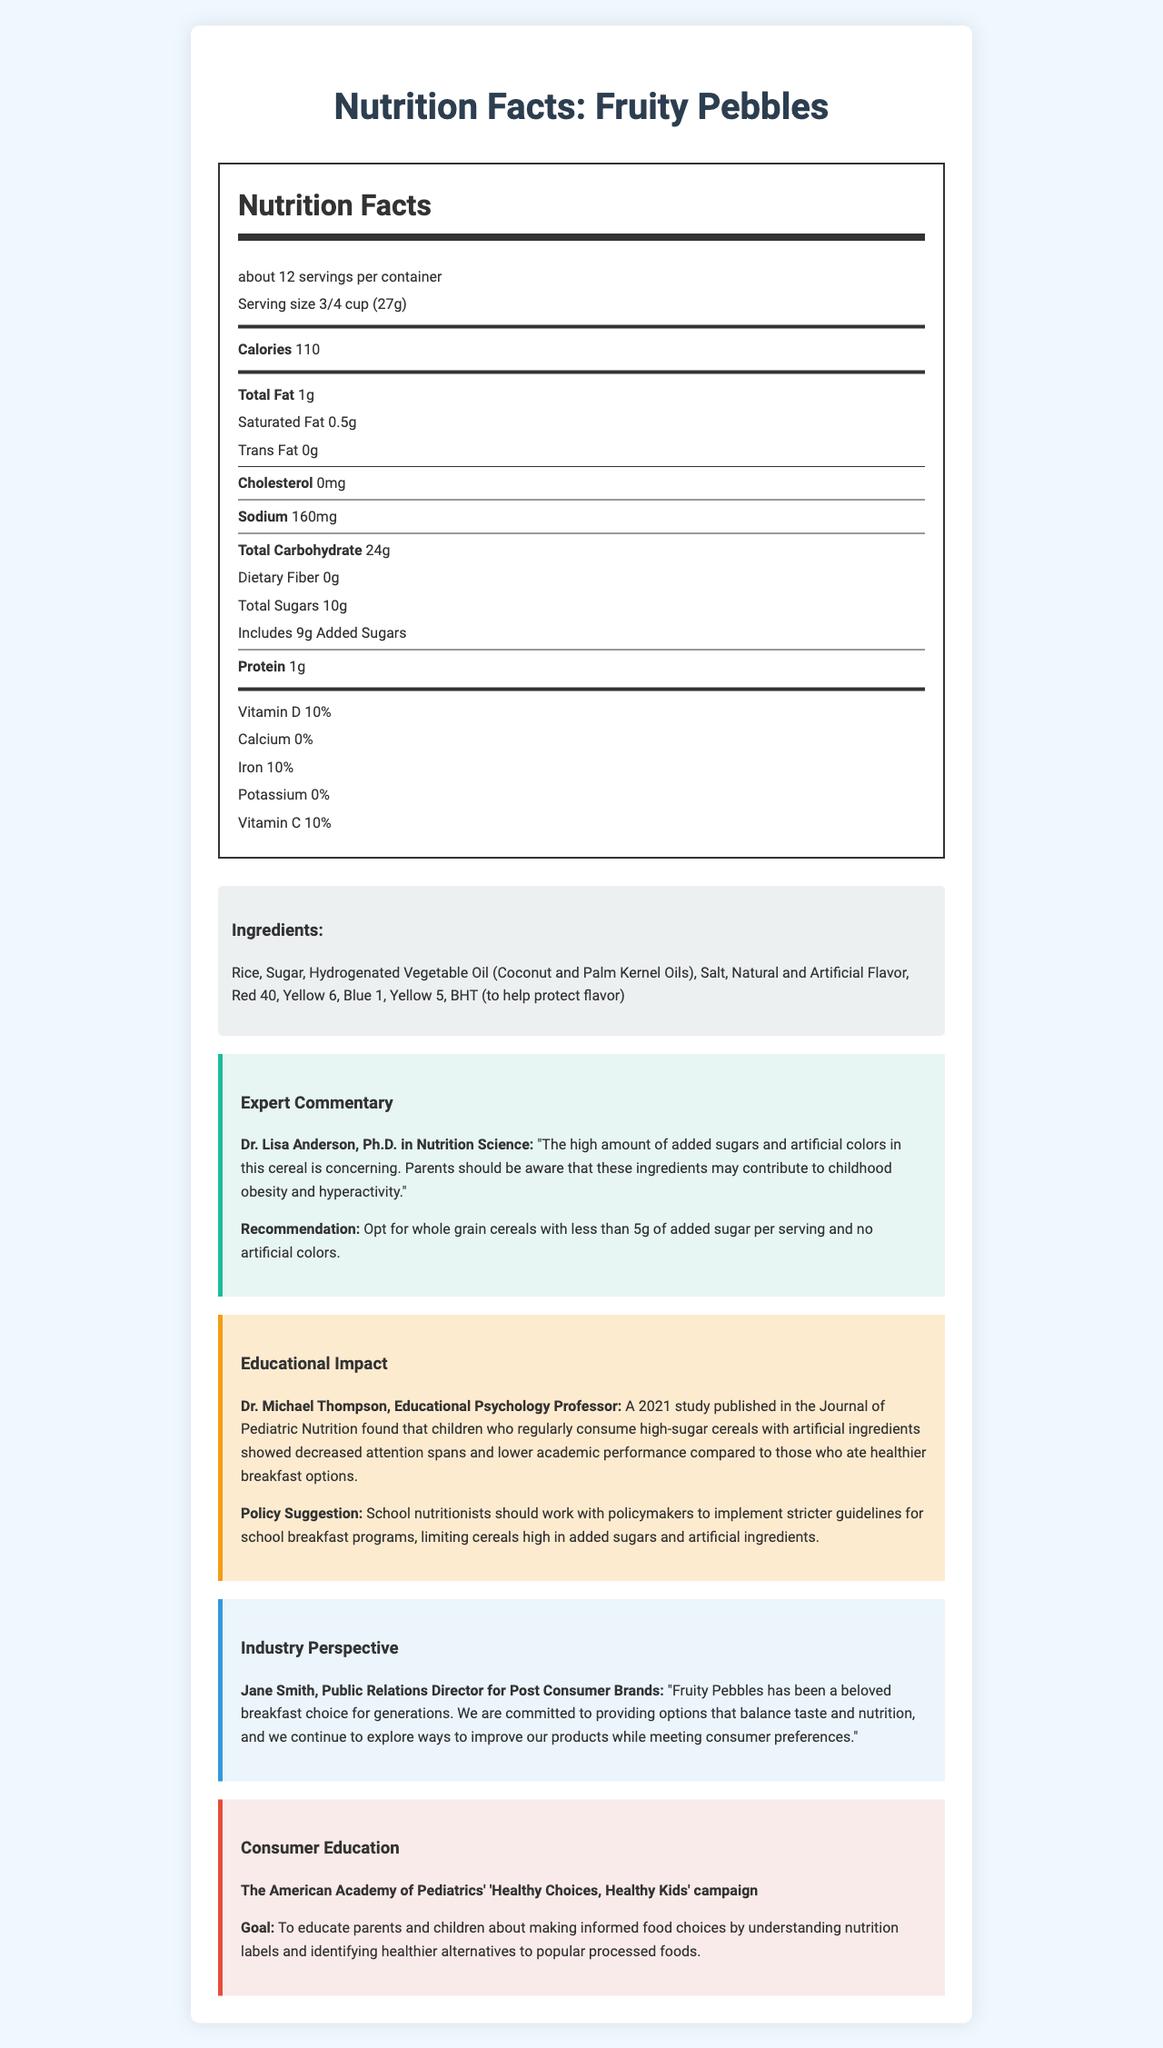what is the product name? The product name is stated at the top of the document.
Answer: Fruity Pebbles how many grams of added sugars are in one serving? The Nutrition Facts section lists 9 grams of added sugars per serving.
Answer: 9g what are the main ingredients? The ingredients list provides these itemized components.
Answer: Rice, Sugar, Hydrogenated Vegetable Oil (Coconut and Palm Kernel Oils), Salt, Natural and Artificial Flavor, Red 40, Yellow 6, Blue 1, Yellow 5, BHT what is the serving size? The serving size is indicated in the Nutrition Facts section.
Answer: 3/4 cup (27g) how many servings are in one container? The Nutrition Facts section specifies there are about 12 servings per container.
Answer: about 12 based on the expert commentary, what recommendation is given for choosing cereals? A. Choose cereals with more than 5g of added sugar B. Choose cereals with artificial colors C. Choose whole grain cereals with less than 5g of added sugar D. Choose cereals high in sodium The expert recommendation is to opt for whole-grain cereals with less than 5g of added sugar per serving and no artificial colors.
Answer: C what is the total carbohydrate content per serving? A. 10g B. 24g C. 12g D. 1g The total carbohydrate content per serving is 24 grams according to the Nutrition Facts label.
Answer: B is there any dietary fiber in Fruity Pebbles? The document states that the Dietary Fiber content is 0g, indicating that there is no dietary fiber.
Answer: No what is the main concern indicated by Dr. Lisa Anderson about the cereal? Dr. Lisa Anderson mentions the high amounts of added sugars and artificial colors as concerning because they may contribute to childhood obesity and hyperactivity.
Answer: High amount of added sugars and artificial colors summarize the main content of this document. The document contains detailed nutritional information, concerns from experts, a manufacturer’s perspective, and information on a consumer education campaign.
Answer: This document provides an overview of the nutritional information for Fruity Pebbles cereal, highlighting its serving size, ingredients, and nutritional content, including added sugars and artificial ingredients. Expert commentary from a nutritionist and an educational psychologist raises concerns about the potential negative health and educational impacts of such ingredients. There is also a perspective from the cereal's manufacturer and information about a consumer education initiative. what is the recommended daily intake percentage of vitamin D per serving? The Nutrition Facts section indicates that each serving provides 10% of the recommended daily intake of Vitamin D.
Answer: 10% how many grams of protein are there per serving? The document lists 1 gram of protein per serving in the Nutrition Facts section.
Answer: 1g who conducted the study that found negative effects of high-sugar cereals on children’s academic performance? Dr. Michael Thompson, an Educational Psychology Professor, is mentioned in the document.
Answer: Dr. Michael Thompson how does the industry spokesperson, Jane Smith, describe Fruity Pebbles? Jane Smith describes Fruity Pebbles as a beloved breakfast choice for generations in the Industry Perspective section.
Answer: A beloved breakfast choice for generations is there any information about allergens in the document? The document does not provide specific details about allergens.
Answer: Not enough information what is the goal of the 'Healthy Choices, Healthy Kids' campaign? The goal of the campaign is stated clearly in the Consumer Education section of the document.
Answer: To educate parents and children about making informed food choices by understanding nutrition labels and identifying healthier alternatives to popular processed foods what percentage of the daily value for iron is in each serving? The Nutrition Facts section lists the daily value for iron as 10% per serving.
Answer: 10% how can the study findings about high-sugar cereals and children's academic performance impact school nutrition policies? The Educational Impact section provides a policy suggestion based on the study findings.
Answer: School nutritionists should work with policymakers to implement stricter guidelines for school breakfast programs, limiting cereals high in added sugars and artificial ingredients. 